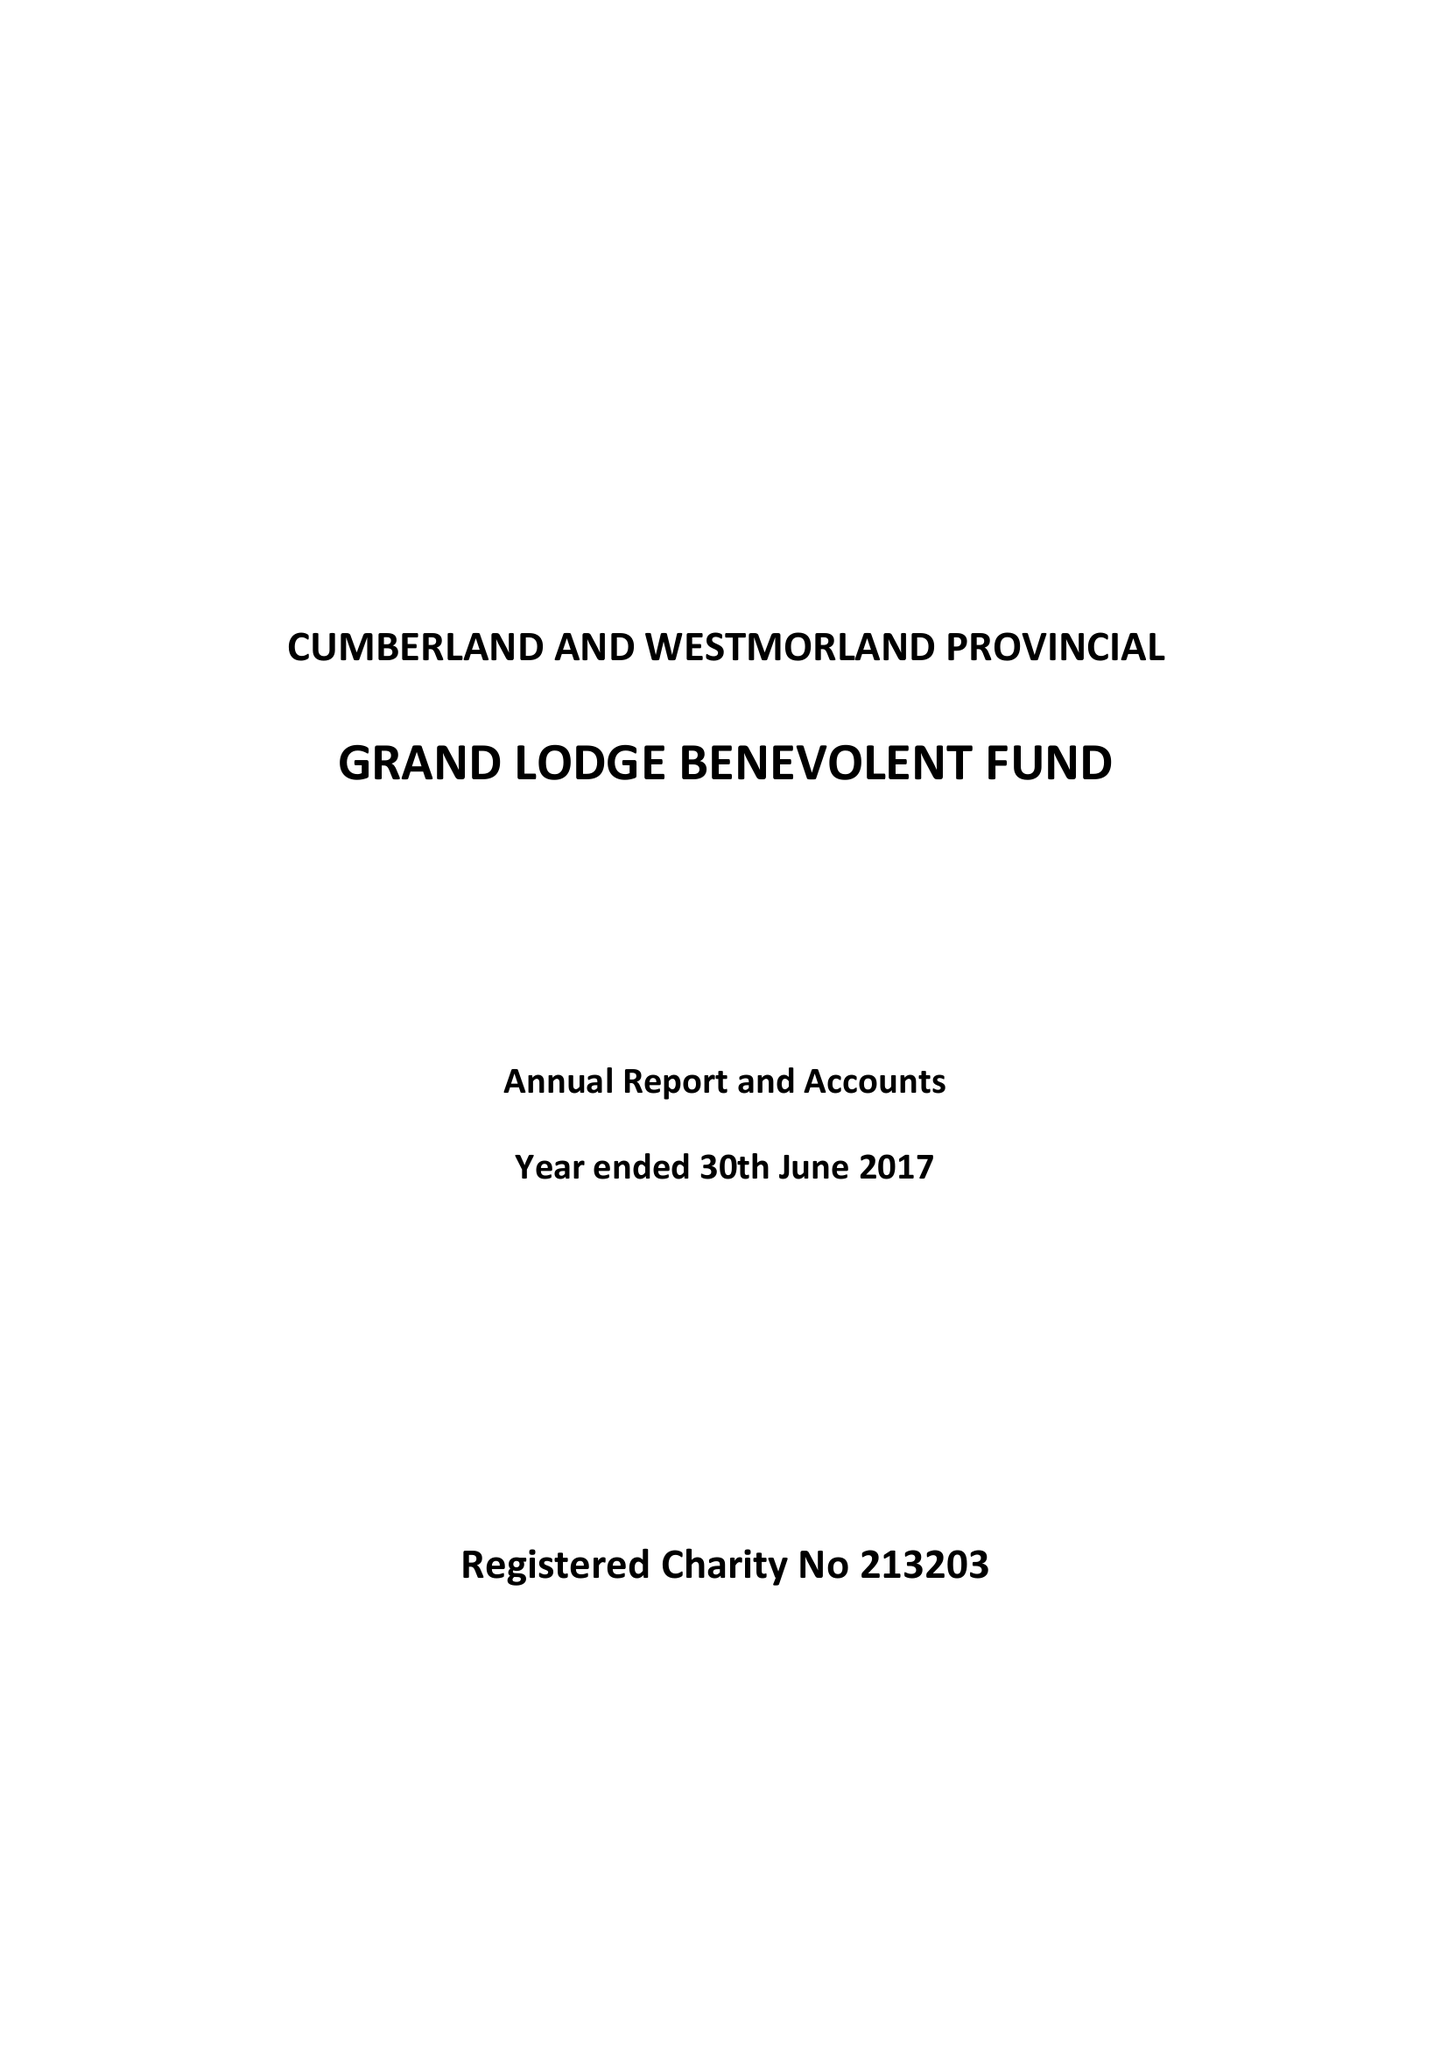What is the value for the report_date?
Answer the question using a single word or phrase. 2017-06-30 